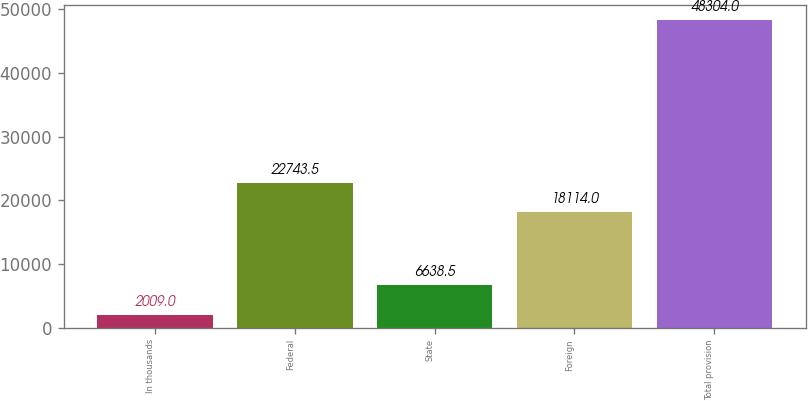<chart> <loc_0><loc_0><loc_500><loc_500><bar_chart><fcel>In thousands<fcel>Federal<fcel>State<fcel>Foreign<fcel>Total provision<nl><fcel>2009<fcel>22743.5<fcel>6638.5<fcel>18114<fcel>48304<nl></chart> 